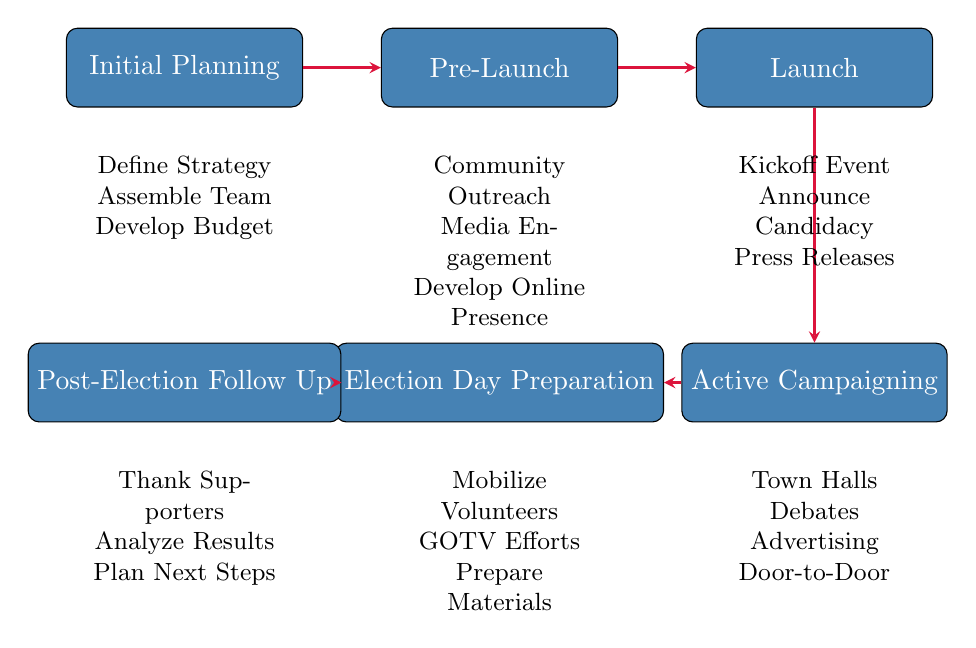What is the first stage of the campaign planning timeline? The first stage is indicated at the top of the flow chart and is labeled "Initial Planning."
Answer: Initial Planning How many stages are there in the campaign planning timeline? By counting the distinct stages represented in the flow chart, we see there are six stages listed.
Answer: Six What activities are associated with the "Launch" stage? The activities listed directly beneath "Launch" indicate that it includes organizing a campaign kickoff event, announcing candidacy publicly, and distributing press releases.
Answer: Organize Campaign Kickoff Event, Announce Candidacy Publicly, Distribute Press Releases Which stage follows "Pre-Launch"? The flow of the arrows in the diagram shows that "Launch" is the stage that comes directly after "Pre-Launch."
Answer: Launch What is one activity listed under "Active Campaigning"? One of the activities listed under "Active Campaigning" is "Host Town Hall Meetings," as indicated in the flow chart.
Answer: Host Town Hall Meetings What is the relationship between "Election Day Preparation" and "Post-Election Follow Up"? The flow chart shows a directional arrow from "Election Day Preparation" to "Post-Election Follow Up," indicating that the preparation leads into the follow-up stage.
Answer: Directional arrow from "Election Day Preparation" to "Post-Election Follow Up" Identify the last stage in the campaign planning timeline. The last stage is at the bottom of the flow chart, labeled "Post-Election Follow Up."
Answer: Post-Election Follow Up What common theme can be inferred from all the stages? Each stage represents a phase in the electoral process aimed at successfully running a campaign, focusing on preparation, action, and reflection.
Answer: Electoral process phases What stage involves community interaction? The "Active Campaigning" stage notably contains activities that engage with the community, such as hosting town hall meetings and canvassing door-to-door.
Answer: Active Campaigning What must be prepared before Election Day? The activities listed before the election day indicate that volunteers must be mobilized, get-out-the-vote efforts coordinated, and materials prepared.
Answer: Mobilize Volunteers, Coordinate Get-Out-The-Vote Efforts, Prepare Election Day Materials 